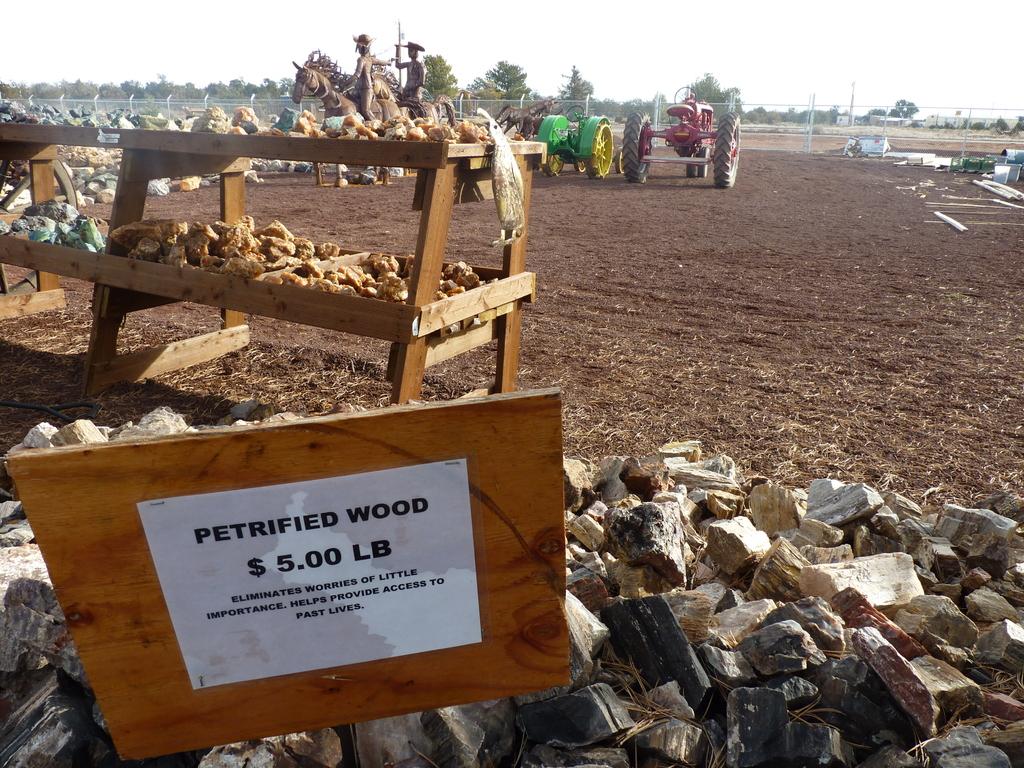Are they selling wood ready for winter season?
Your answer should be compact. Unanswerable. How much are they selling petrified wood for?
Keep it short and to the point. $5.00 lb. 